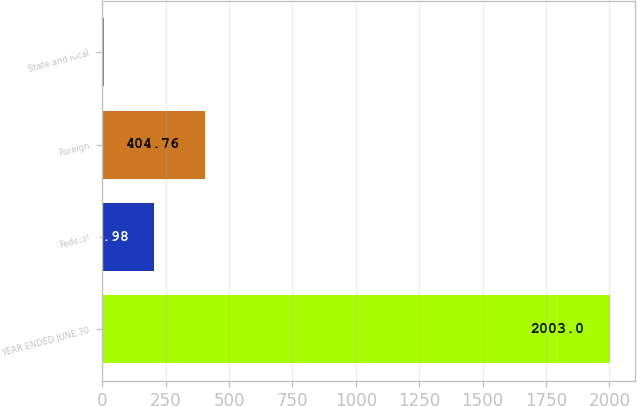Convert chart. <chart><loc_0><loc_0><loc_500><loc_500><bar_chart><fcel>YEAR ENDED JUNE 30<fcel>Federal<fcel>Foreign<fcel>State and local<nl><fcel>2003<fcel>204.98<fcel>404.76<fcel>5.2<nl></chart> 